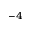<formula> <loc_0><loc_0><loc_500><loc_500>^ { - 4 }</formula> 